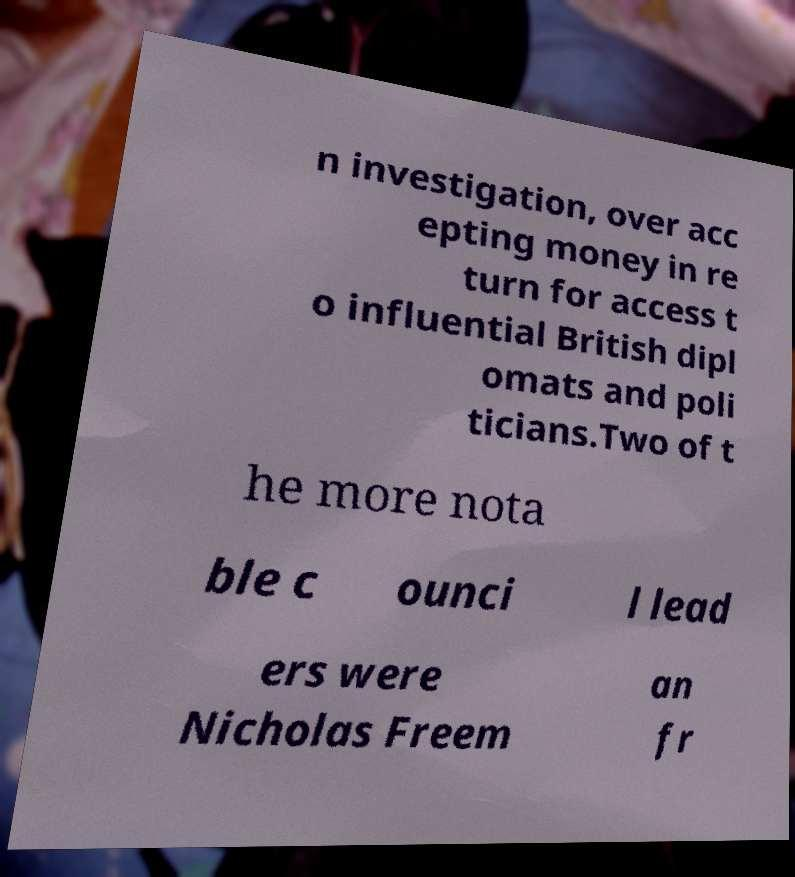Could you assist in decoding the text presented in this image and type it out clearly? n investigation, over acc epting money in re turn for access t o influential British dipl omats and poli ticians.Two of t he more nota ble c ounci l lead ers were Nicholas Freem an fr 